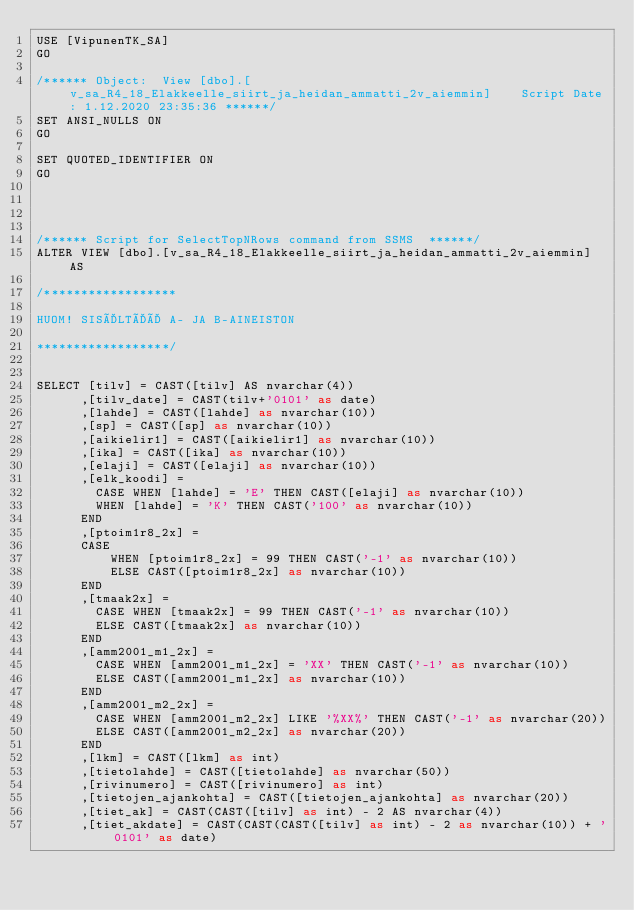<code> <loc_0><loc_0><loc_500><loc_500><_SQL_>USE [VipunenTK_SA]
GO

/****** Object:  View [dbo].[v_sa_R4_18_Elakkeelle_siirt_ja_heidan_ammatti_2v_aiemmin]    Script Date: 1.12.2020 23:35:36 ******/
SET ANSI_NULLS ON
GO

SET QUOTED_IDENTIFIER ON
GO




/****** Script for SelectTopNRows command from SSMS  ******/
ALTER VIEW [dbo].[v_sa_R4_18_Elakkeelle_siirt_ja_heidan_ammatti_2v_aiemmin] AS

/******************

HUOM! SISÄLTÄÄ A- JA B-AINEISTON

******************/


SELECT [tilv] = CAST([tilv] AS nvarchar(4))
	  ,[tilv_date] = CAST(tilv+'0101' as date)
      ,[lahde] = CAST([lahde] as nvarchar(10))
      ,[sp] = CAST([sp] as nvarchar(10))
      ,[aikielir1] = CAST([aikielir1] as nvarchar(10))
      ,[ika] = CAST([ika] as nvarchar(10))
      ,[elaji] = CAST([elaji] as nvarchar(10))
      ,[elk_koodi] = 
		CASE WHEN [lahde] = 'E' THEN CAST([elaji] as nvarchar(10))      
		WHEN [lahde] = 'K' THEN CAST('100' as nvarchar(10))     
      END      
      ,[ptoim1r8_2x] = 
      CASE
          WHEN [ptoim1r8_2x] = 99 THEN CAST('-1' as nvarchar(10))
          ELSE CAST([ptoim1r8_2x] as nvarchar(10))
      END
      ,[tmaak2x] = 
		CASE WHEN [tmaak2x] = 99 THEN CAST('-1' as nvarchar(10))
		ELSE CAST([tmaak2x] as nvarchar(10))
      END      
      ,[amm2001_m1_2x] = 
		CASE WHEN [amm2001_m1_2x] = 'XX' THEN CAST('-1' as nvarchar(10))
		ELSE CAST([amm2001_m1_2x] as nvarchar(10))
      END
      ,[amm2001_m2_2x] = 
		CASE WHEN [amm2001_m2_2x] LIKE '%XX%' THEN CAST('-1' as nvarchar(20))
		ELSE CAST([amm2001_m2_2x] as nvarchar(20))
	  END
      ,[lkm] = CAST([lkm] as int)
      ,[tietolahde] = CAST([tietolahde] as nvarchar(50))
      ,[rivinumero] = CAST([rivinumero] as int)
      ,[tietojen_ajankohta] = CAST([tietojen_ajankohta] as nvarchar(20))
      ,[tiet_ak] = CAST(CAST([tilv] as int) - 2 AS nvarchar(4))
      ,[tiet_akdate] = CAST(CAST(CAST([tilv] as int) - 2 as nvarchar(10)) + '0101' as date)   </code> 